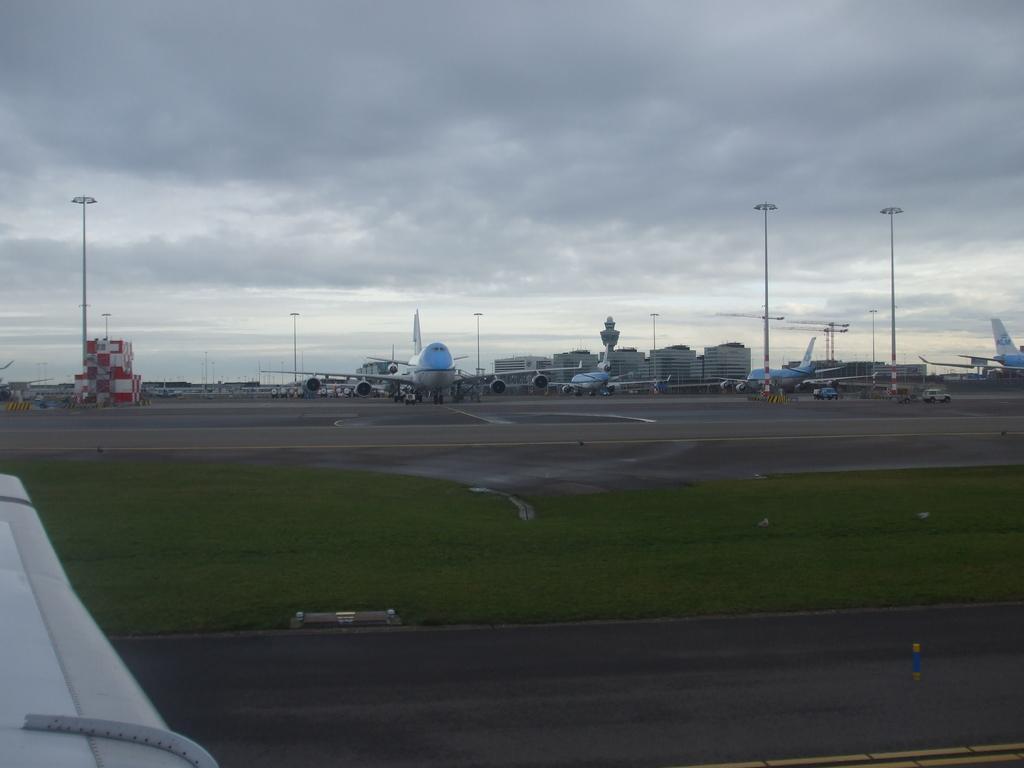How would you summarize this image in a sentence or two? In this image there are so many planes in the runway, behind that there are buildings and electric poles. 